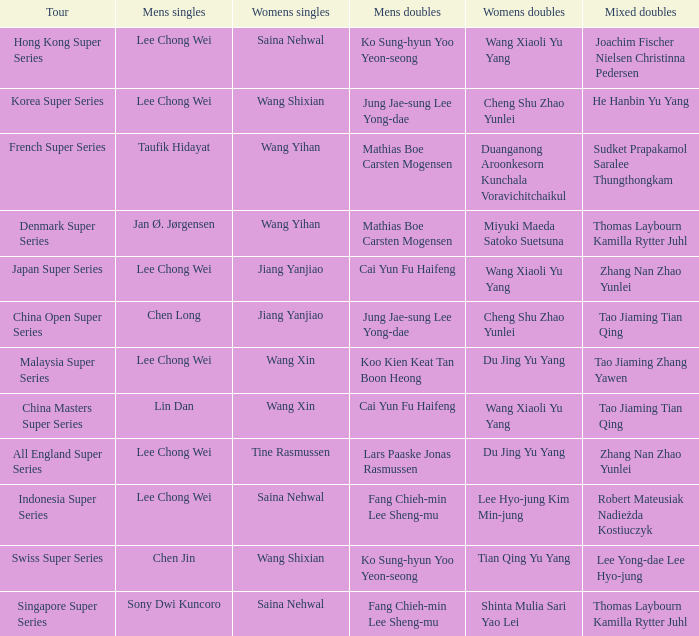Who is the mixed doubled on the tour korea super series? He Hanbin Yu Yang. 